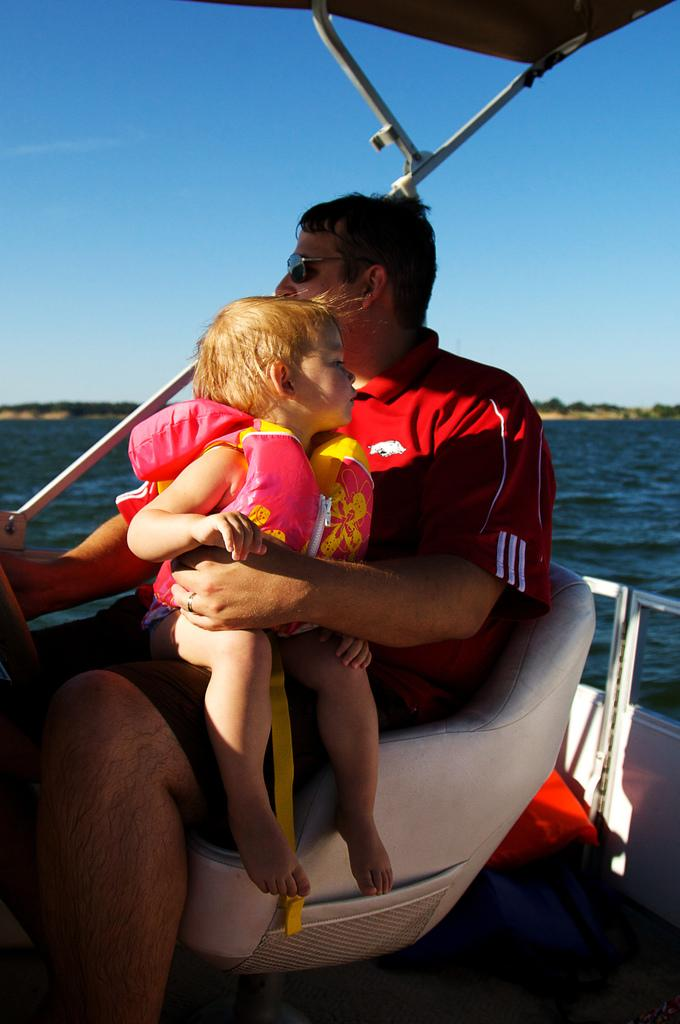What is the man in the image doing? The man is sitting on a chair and holding a kid in the image. What color is the object in the image? There is a red object in the image. What can be seen in the background of the image? There are trees and the sky visible in the background of the image. What is the man holding in his hand? The man is holding a kid in the image. What is the purpose of the rods in the image? The purpose of the rods in the image is not clear from the provided facts. What type of sink can be seen in the image? There is no sink present in the image. Is the man's grandfather also in the image? The provided facts do not mention the presence of a grandfather in the image. 